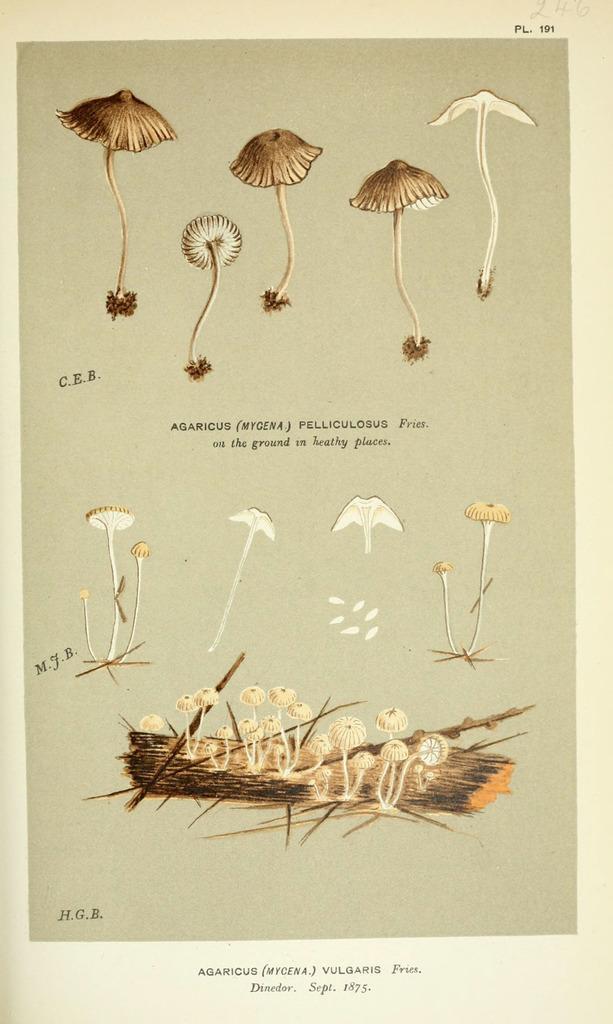How would you summarize this image in a sentence or two? This image looks like a paper. There are some pictures of mushrooms in this image. 